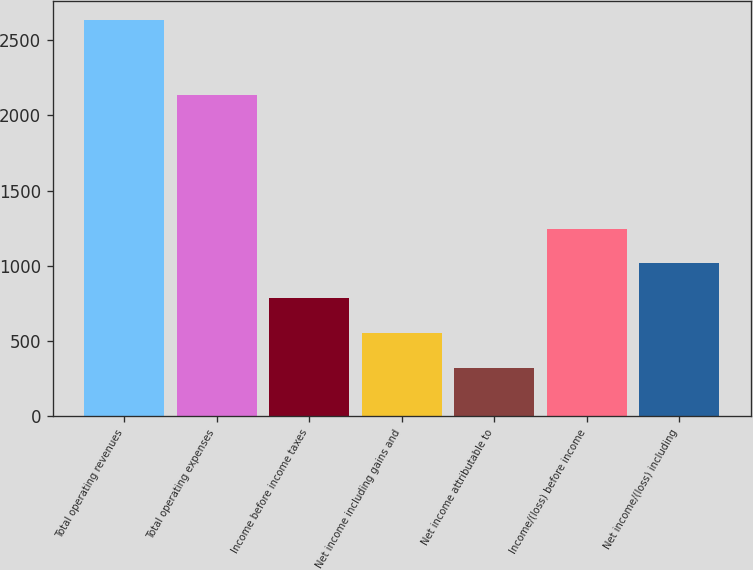Convert chart to OTSL. <chart><loc_0><loc_0><loc_500><loc_500><bar_chart><fcel>Total operating revenues<fcel>Total operating expenses<fcel>Income before income taxes<fcel>Net income including gains and<fcel>Net income attributable to<fcel>Income/(loss) before income<fcel>Net income/(loss) including<nl><fcel>2633.3<fcel>2139.5<fcel>784.66<fcel>553.58<fcel>322.5<fcel>1246.82<fcel>1015.74<nl></chart> 